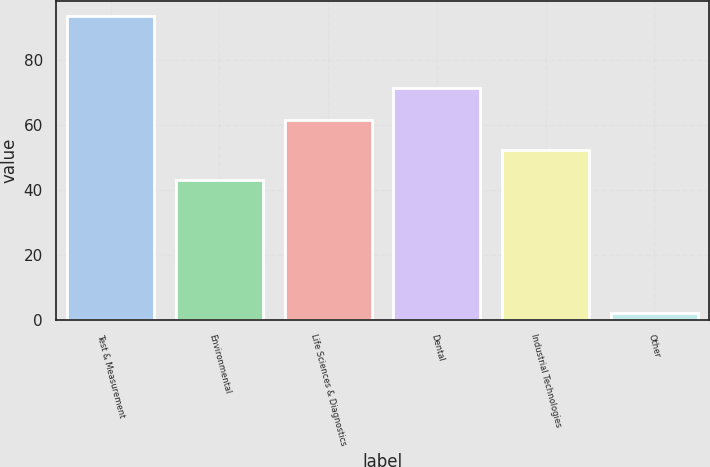<chart> <loc_0><loc_0><loc_500><loc_500><bar_chart><fcel>Test & Measurement<fcel>Environmental<fcel>Life Sciences & Diagnostics<fcel>Dental<fcel>Industrial Technologies<fcel>Other<nl><fcel>93.5<fcel>43.1<fcel>61.4<fcel>71.3<fcel>52.25<fcel>2<nl></chart> 